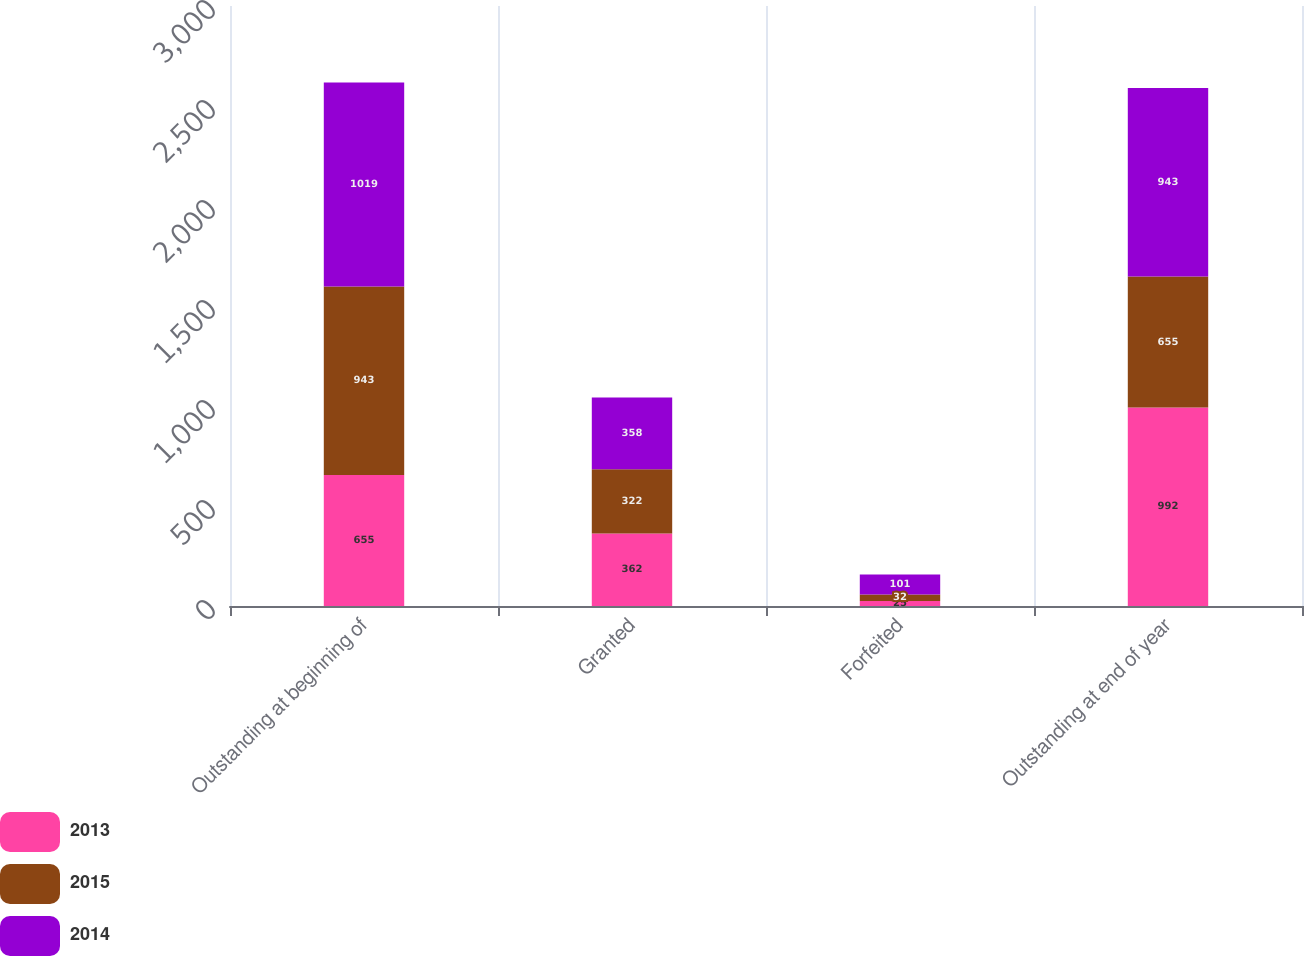Convert chart to OTSL. <chart><loc_0><loc_0><loc_500><loc_500><stacked_bar_chart><ecel><fcel>Outstanding at beginning of<fcel>Granted<fcel>Forfeited<fcel>Outstanding at end of year<nl><fcel>2013<fcel>655<fcel>362<fcel>25<fcel>992<nl><fcel>2015<fcel>943<fcel>322<fcel>32<fcel>655<nl><fcel>2014<fcel>1019<fcel>358<fcel>101<fcel>943<nl></chart> 